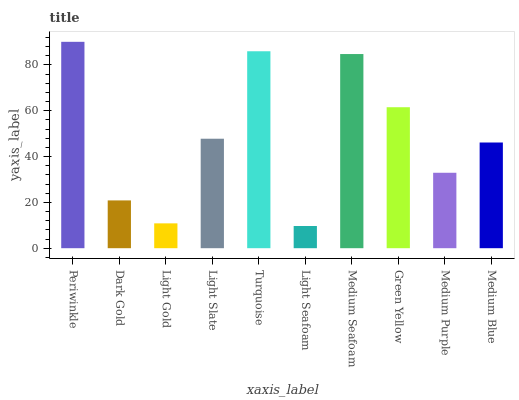Is Light Seafoam the minimum?
Answer yes or no. Yes. Is Periwinkle the maximum?
Answer yes or no. Yes. Is Dark Gold the minimum?
Answer yes or no. No. Is Dark Gold the maximum?
Answer yes or no. No. Is Periwinkle greater than Dark Gold?
Answer yes or no. Yes. Is Dark Gold less than Periwinkle?
Answer yes or no. Yes. Is Dark Gold greater than Periwinkle?
Answer yes or no. No. Is Periwinkle less than Dark Gold?
Answer yes or no. No. Is Light Slate the high median?
Answer yes or no. Yes. Is Medium Blue the low median?
Answer yes or no. Yes. Is Light Gold the high median?
Answer yes or no. No. Is Medium Purple the low median?
Answer yes or no. No. 